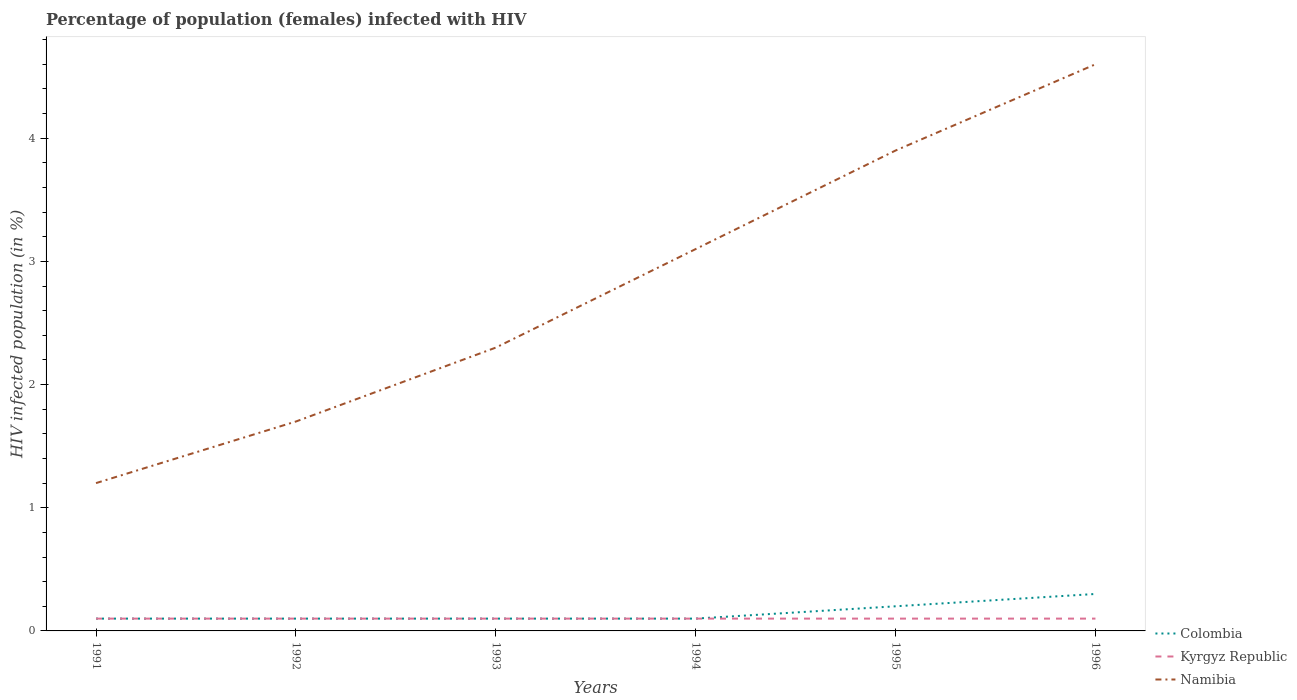Across all years, what is the maximum percentage of HIV infected female population in Namibia?
Provide a succinct answer. 1.2. What is the total percentage of HIV infected female population in Kyrgyz Republic in the graph?
Keep it short and to the point. 0. What is the difference between the highest and the second highest percentage of HIV infected female population in Colombia?
Your answer should be compact. 0.2. What is the difference between the highest and the lowest percentage of HIV infected female population in Namibia?
Keep it short and to the point. 3. How many lines are there?
Offer a terse response. 3. Does the graph contain grids?
Keep it short and to the point. No. How are the legend labels stacked?
Your answer should be compact. Vertical. What is the title of the graph?
Provide a short and direct response. Percentage of population (females) infected with HIV. Does "Yemen, Rep." appear as one of the legend labels in the graph?
Make the answer very short. No. What is the label or title of the X-axis?
Your answer should be compact. Years. What is the label or title of the Y-axis?
Offer a terse response. HIV infected population (in %). What is the HIV infected population (in %) in Kyrgyz Republic in 1991?
Give a very brief answer. 0.1. What is the HIV infected population (in %) in Namibia in 1991?
Your answer should be compact. 1.2. What is the HIV infected population (in %) of Kyrgyz Republic in 1992?
Give a very brief answer. 0.1. What is the HIV infected population (in %) of Namibia in 1992?
Your response must be concise. 1.7. What is the HIV infected population (in %) of Kyrgyz Republic in 1993?
Offer a terse response. 0.1. What is the HIV infected population (in %) of Namibia in 1993?
Your answer should be compact. 2.3. What is the HIV infected population (in %) of Colombia in 1994?
Provide a succinct answer. 0.1. What is the HIV infected population (in %) in Kyrgyz Republic in 1994?
Your answer should be very brief. 0.1. What is the HIV infected population (in %) of Namibia in 1994?
Give a very brief answer. 3.1. What is the HIV infected population (in %) of Colombia in 1995?
Ensure brevity in your answer.  0.2. What is the HIV infected population (in %) in Kyrgyz Republic in 1995?
Keep it short and to the point. 0.1. What is the HIV infected population (in %) of Namibia in 1995?
Offer a very short reply. 3.9. What is the HIV infected population (in %) in Colombia in 1996?
Your response must be concise. 0.3. What is the HIV infected population (in %) of Namibia in 1996?
Keep it short and to the point. 4.6. Across all years, what is the maximum HIV infected population (in %) of Colombia?
Your response must be concise. 0.3. Across all years, what is the minimum HIV infected population (in %) in Colombia?
Provide a succinct answer. 0.1. Across all years, what is the minimum HIV infected population (in %) in Namibia?
Offer a terse response. 1.2. What is the total HIV infected population (in %) in Namibia in the graph?
Keep it short and to the point. 16.8. What is the difference between the HIV infected population (in %) of Colombia in 1991 and that in 1993?
Offer a terse response. 0. What is the difference between the HIV infected population (in %) of Kyrgyz Republic in 1991 and that in 1993?
Your answer should be compact. 0. What is the difference between the HIV infected population (in %) in Colombia in 1991 and that in 1994?
Offer a terse response. 0. What is the difference between the HIV infected population (in %) of Kyrgyz Republic in 1991 and that in 1994?
Keep it short and to the point. 0. What is the difference between the HIV infected population (in %) of Namibia in 1991 and that in 1994?
Offer a terse response. -1.9. What is the difference between the HIV infected population (in %) in Namibia in 1991 and that in 1995?
Offer a terse response. -2.7. What is the difference between the HIV infected population (in %) of Colombia in 1991 and that in 1996?
Make the answer very short. -0.2. What is the difference between the HIV infected population (in %) of Namibia in 1991 and that in 1996?
Provide a short and direct response. -3.4. What is the difference between the HIV infected population (in %) in Kyrgyz Republic in 1992 and that in 1993?
Your answer should be compact. 0. What is the difference between the HIV infected population (in %) of Namibia in 1992 and that in 1993?
Ensure brevity in your answer.  -0.6. What is the difference between the HIV infected population (in %) of Namibia in 1992 and that in 1994?
Your answer should be compact. -1.4. What is the difference between the HIV infected population (in %) of Colombia in 1992 and that in 1995?
Your response must be concise. -0.1. What is the difference between the HIV infected population (in %) in Kyrgyz Republic in 1992 and that in 1995?
Keep it short and to the point. 0. What is the difference between the HIV infected population (in %) of Namibia in 1992 and that in 1995?
Provide a short and direct response. -2.2. What is the difference between the HIV infected population (in %) in Colombia in 1992 and that in 1996?
Provide a short and direct response. -0.2. What is the difference between the HIV infected population (in %) of Namibia in 1992 and that in 1996?
Provide a short and direct response. -2.9. What is the difference between the HIV infected population (in %) in Colombia in 1993 and that in 1995?
Your answer should be very brief. -0.1. What is the difference between the HIV infected population (in %) of Namibia in 1993 and that in 1995?
Your answer should be compact. -1.6. What is the difference between the HIV infected population (in %) in Kyrgyz Republic in 1993 and that in 1996?
Your answer should be compact. 0. What is the difference between the HIV infected population (in %) in Namibia in 1993 and that in 1996?
Ensure brevity in your answer.  -2.3. What is the difference between the HIV infected population (in %) of Colombia in 1994 and that in 1995?
Provide a short and direct response. -0.1. What is the difference between the HIV infected population (in %) in Kyrgyz Republic in 1994 and that in 1995?
Give a very brief answer. 0. What is the difference between the HIV infected population (in %) in Colombia in 1994 and that in 1996?
Offer a terse response. -0.2. What is the difference between the HIV infected population (in %) of Namibia in 1994 and that in 1996?
Ensure brevity in your answer.  -1.5. What is the difference between the HIV infected population (in %) of Namibia in 1995 and that in 1996?
Your response must be concise. -0.7. What is the difference between the HIV infected population (in %) in Colombia in 1992 and the HIV infected population (in %) in Kyrgyz Republic in 1993?
Your response must be concise. 0. What is the difference between the HIV infected population (in %) of Colombia in 1992 and the HIV infected population (in %) of Namibia in 1994?
Your answer should be very brief. -3. What is the difference between the HIV infected population (in %) in Kyrgyz Republic in 1992 and the HIV infected population (in %) in Namibia in 1995?
Make the answer very short. -3.8. What is the difference between the HIV infected population (in %) of Kyrgyz Republic in 1992 and the HIV infected population (in %) of Namibia in 1996?
Keep it short and to the point. -4.5. What is the difference between the HIV infected population (in %) in Colombia in 1993 and the HIV infected population (in %) in Namibia in 1994?
Ensure brevity in your answer.  -3. What is the difference between the HIV infected population (in %) in Colombia in 1993 and the HIV infected population (in %) in Namibia in 1995?
Provide a short and direct response. -3.8. What is the difference between the HIV infected population (in %) in Kyrgyz Republic in 1993 and the HIV infected population (in %) in Namibia in 1995?
Your answer should be compact. -3.8. What is the difference between the HIV infected population (in %) of Colombia in 1993 and the HIV infected population (in %) of Kyrgyz Republic in 1996?
Provide a succinct answer. 0. What is the difference between the HIV infected population (in %) in Kyrgyz Republic in 1993 and the HIV infected population (in %) in Namibia in 1996?
Offer a terse response. -4.5. What is the difference between the HIV infected population (in %) in Colombia in 1994 and the HIV infected population (in %) in Kyrgyz Republic in 1996?
Provide a short and direct response. 0. What is the difference between the HIV infected population (in %) in Colombia in 1994 and the HIV infected population (in %) in Namibia in 1996?
Offer a terse response. -4.5. What is the difference between the HIV infected population (in %) in Colombia in 1995 and the HIV infected population (in %) in Kyrgyz Republic in 1996?
Offer a very short reply. 0.1. What is the difference between the HIV infected population (in %) of Colombia in 1995 and the HIV infected population (in %) of Namibia in 1996?
Offer a terse response. -4.4. What is the average HIV infected population (in %) of Colombia per year?
Make the answer very short. 0.15. What is the average HIV infected population (in %) of Kyrgyz Republic per year?
Your answer should be very brief. 0.1. In the year 1991, what is the difference between the HIV infected population (in %) in Colombia and HIV infected population (in %) in Kyrgyz Republic?
Keep it short and to the point. 0. In the year 1992, what is the difference between the HIV infected population (in %) in Colombia and HIV infected population (in %) in Namibia?
Give a very brief answer. -1.6. In the year 1993, what is the difference between the HIV infected population (in %) of Colombia and HIV infected population (in %) of Namibia?
Your response must be concise. -2.2. In the year 1993, what is the difference between the HIV infected population (in %) in Kyrgyz Republic and HIV infected population (in %) in Namibia?
Ensure brevity in your answer.  -2.2. In the year 1994, what is the difference between the HIV infected population (in %) in Colombia and HIV infected population (in %) in Kyrgyz Republic?
Your answer should be compact. 0. In the year 1994, what is the difference between the HIV infected population (in %) in Colombia and HIV infected population (in %) in Namibia?
Your response must be concise. -3. In the year 1995, what is the difference between the HIV infected population (in %) in Kyrgyz Republic and HIV infected population (in %) in Namibia?
Keep it short and to the point. -3.8. What is the ratio of the HIV infected population (in %) of Kyrgyz Republic in 1991 to that in 1992?
Your answer should be compact. 1. What is the ratio of the HIV infected population (in %) of Namibia in 1991 to that in 1992?
Give a very brief answer. 0.71. What is the ratio of the HIV infected population (in %) of Namibia in 1991 to that in 1993?
Make the answer very short. 0.52. What is the ratio of the HIV infected population (in %) of Kyrgyz Republic in 1991 to that in 1994?
Provide a succinct answer. 1. What is the ratio of the HIV infected population (in %) of Namibia in 1991 to that in 1994?
Keep it short and to the point. 0.39. What is the ratio of the HIV infected population (in %) of Colombia in 1991 to that in 1995?
Your answer should be compact. 0.5. What is the ratio of the HIV infected population (in %) of Namibia in 1991 to that in 1995?
Provide a succinct answer. 0.31. What is the ratio of the HIV infected population (in %) in Namibia in 1991 to that in 1996?
Keep it short and to the point. 0.26. What is the ratio of the HIV infected population (in %) in Colombia in 1992 to that in 1993?
Provide a succinct answer. 1. What is the ratio of the HIV infected population (in %) of Kyrgyz Republic in 1992 to that in 1993?
Give a very brief answer. 1. What is the ratio of the HIV infected population (in %) in Namibia in 1992 to that in 1993?
Your answer should be very brief. 0.74. What is the ratio of the HIV infected population (in %) of Namibia in 1992 to that in 1994?
Provide a short and direct response. 0.55. What is the ratio of the HIV infected population (in %) in Colombia in 1992 to that in 1995?
Give a very brief answer. 0.5. What is the ratio of the HIV infected population (in %) in Namibia in 1992 to that in 1995?
Ensure brevity in your answer.  0.44. What is the ratio of the HIV infected population (in %) in Colombia in 1992 to that in 1996?
Your answer should be compact. 0.33. What is the ratio of the HIV infected population (in %) of Kyrgyz Republic in 1992 to that in 1996?
Ensure brevity in your answer.  1. What is the ratio of the HIV infected population (in %) in Namibia in 1992 to that in 1996?
Offer a terse response. 0.37. What is the ratio of the HIV infected population (in %) in Colombia in 1993 to that in 1994?
Ensure brevity in your answer.  1. What is the ratio of the HIV infected population (in %) in Namibia in 1993 to that in 1994?
Your answer should be very brief. 0.74. What is the ratio of the HIV infected population (in %) in Namibia in 1993 to that in 1995?
Offer a terse response. 0.59. What is the ratio of the HIV infected population (in %) of Kyrgyz Republic in 1993 to that in 1996?
Offer a very short reply. 1. What is the ratio of the HIV infected population (in %) in Kyrgyz Republic in 1994 to that in 1995?
Provide a succinct answer. 1. What is the ratio of the HIV infected population (in %) in Namibia in 1994 to that in 1995?
Your answer should be compact. 0.79. What is the ratio of the HIV infected population (in %) in Colombia in 1994 to that in 1996?
Offer a terse response. 0.33. What is the ratio of the HIV infected population (in %) of Namibia in 1994 to that in 1996?
Ensure brevity in your answer.  0.67. What is the ratio of the HIV infected population (in %) of Colombia in 1995 to that in 1996?
Offer a very short reply. 0.67. What is the ratio of the HIV infected population (in %) in Namibia in 1995 to that in 1996?
Your answer should be very brief. 0.85. What is the difference between the highest and the second highest HIV infected population (in %) of Kyrgyz Republic?
Make the answer very short. 0. What is the difference between the highest and the second highest HIV infected population (in %) of Namibia?
Keep it short and to the point. 0.7. What is the difference between the highest and the lowest HIV infected population (in %) of Kyrgyz Republic?
Your response must be concise. 0. 